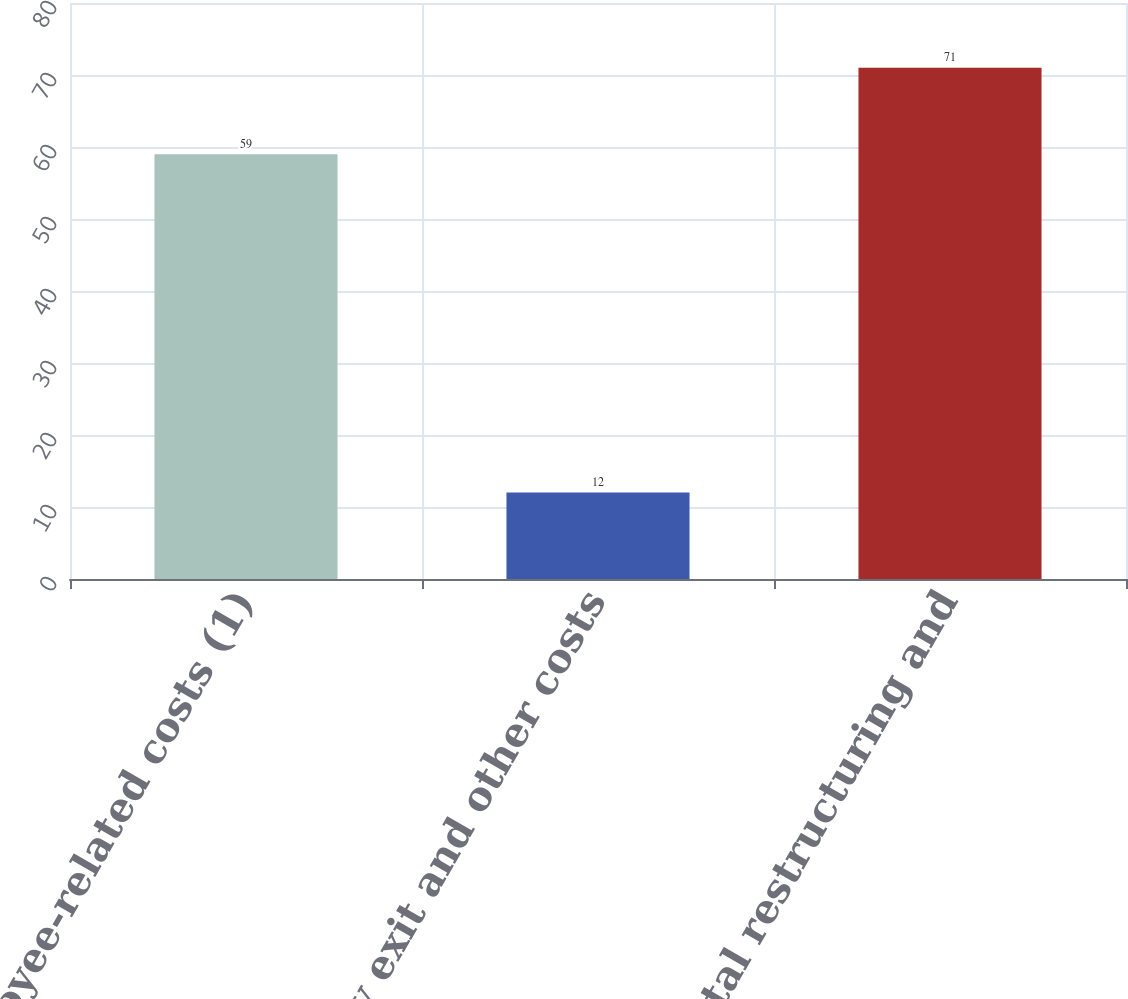<chart> <loc_0><loc_0><loc_500><loc_500><bar_chart><fcel>Employee-related costs (1)<fcel>Facility exit and other costs<fcel>Total restructuring and<nl><fcel>59<fcel>12<fcel>71<nl></chart> 